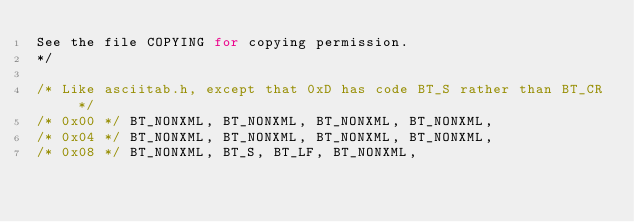<code> <loc_0><loc_0><loc_500><loc_500><_C_>See the file COPYING for copying permission.
*/

/* Like asciitab.h, except that 0xD has code BT_S rather than BT_CR */
/* 0x00 */ BT_NONXML, BT_NONXML, BT_NONXML, BT_NONXML,
/* 0x04 */ BT_NONXML, BT_NONXML, BT_NONXML, BT_NONXML,
/* 0x08 */ BT_NONXML, BT_S, BT_LF, BT_NONXML,</code> 